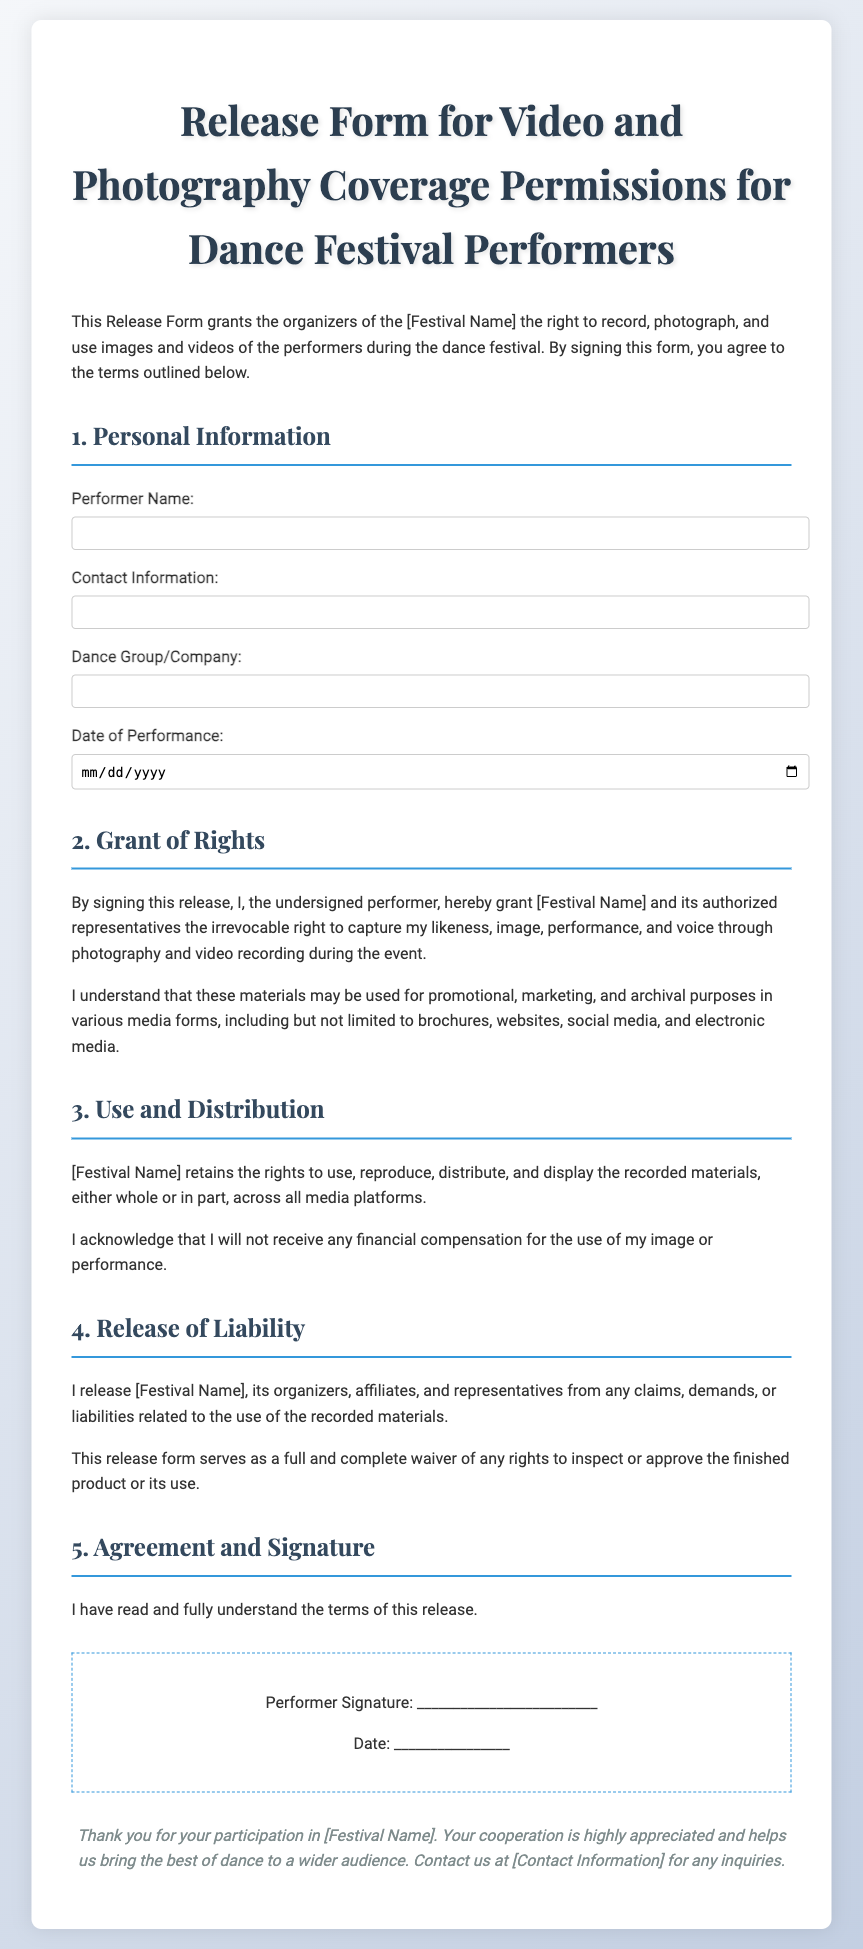What is the title of the document? The title is prominently displayed at the top of the document, indicating its purpose.
Answer: Release Form for Video and Photography Coverage Permissions for Dance Festival Performers What is the name of the festival? The document references the festival name in brackets, indicating it is customizable and should be filled in.
Answer: [Festival Name] What information is required from the performer? The sections listed in the form specify what personal details need to be provided.
Answer: Performer Name, Contact Information, Dance Group/Company, Date of Performance What rights does the performer grant by signing? The document outlines the rights transferred to the festival, detailing the scope of usage of the materials.
Answer: Irrevocable right to capture my likeness, image, performance, and voice Will the performer receive compensation? The document specifically addresses payment in relation to the use of recorded materials.
Answer: No What is the signature for? The signature section confirms the performer's agreement to the terms laid out in the document.
Answer: To signify agreement to the terms What does the performer release the festival from? The document's clauses include a release of claims regarding the usage of recorded materials.
Answer: Claims, demands, or liabilities related to the use of the recorded materials What is included in the use and distribution rights? The document mentions the various media platforms where the recorded materials can be used.
Answer: All media platforms What type of waiver does the document serve as? The document explicitly mentions the nature of the waiver related to approval of the finished product.
Answer: Full and complete waiver 